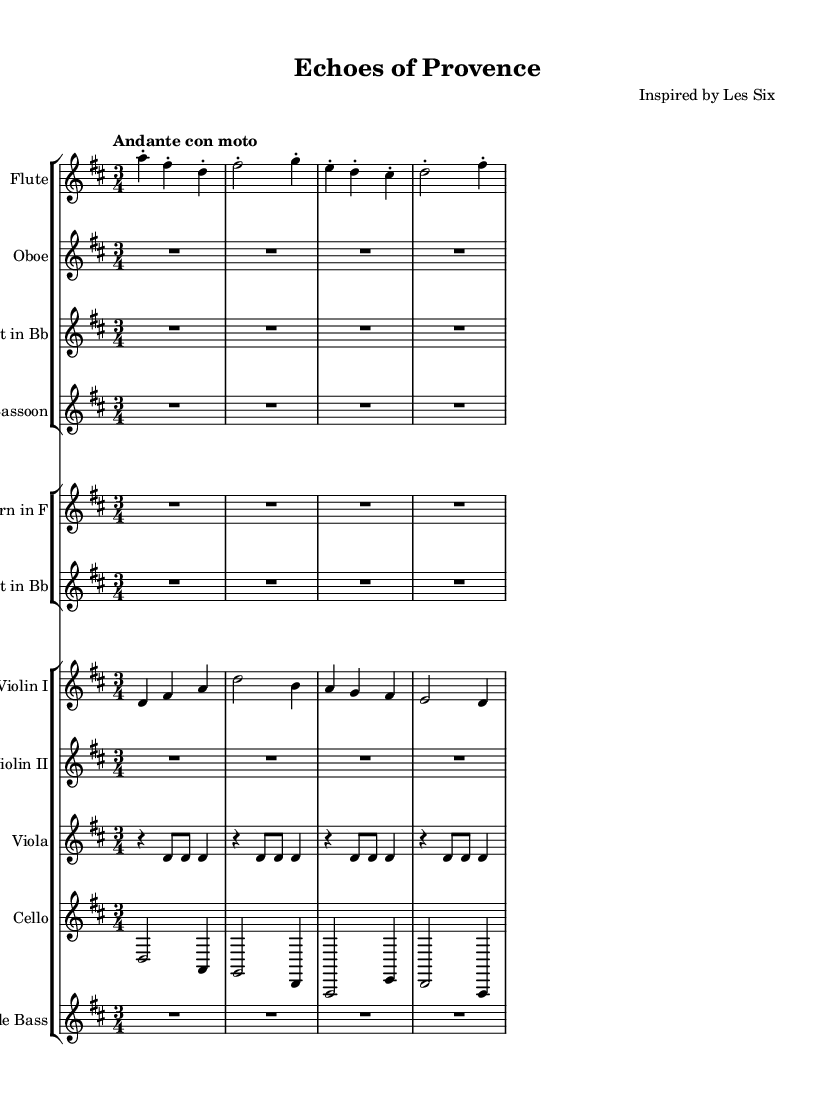What is the key signature of this music? The key signature is indicated in the global section of the code; it states \key d \major, meaning the piece is in D major.
Answer: D major What is the time signature of this music? The time signature is found in the global section, which specifies \time 3/4, indicating a three-quarter note measure.
Answer: 3/4 What is the tempo marking of this piece? The tempo is given as "Andante con moto" in the global section, indicating a moderately slow tempo with movement.
Answer: Andante con moto How many measures are in the flute part? Counting the measure counts in the flute part, we see there are 5 measures indicated by the notation.
Answer: 5 Which instruments have rest measures? The oboe, clarinet, bassoon, and viola all have entire measures indicated with 'R' (rest) in their respective parts, confirming they do not play in these measures.
Answer: Oboe, Clarinet, Bassoon, Viola What is the rhythmic pattern common to all string instruments in the first few measures? In the violin I, violin II, viola, and cello parts, the common pattern features a combination of quarter notes and half notes within their measures.
Answer: Quarter notes and half notes Which instrument plays the lowest pitch in this score? By examining the parts, the cello's notes, being transposed lower than the other instruments, indicate that it plays the lowest pitch within the ensemble.
Answer: Cello 